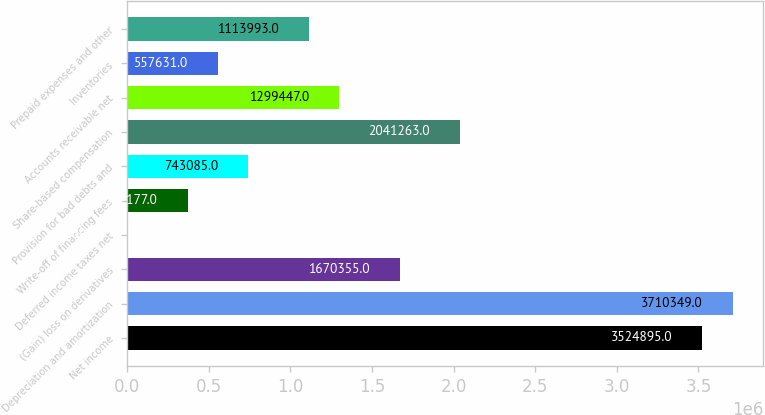Convert chart. <chart><loc_0><loc_0><loc_500><loc_500><bar_chart><fcel>Net income<fcel>Depreciation and amortization<fcel>(Gain) loss on derivatives<fcel>Deferred income taxes net<fcel>Write-off of financing fees<fcel>Provision for bad debts and<fcel>Share-based compensation<fcel>Accounts receivable net<fcel>Inventories<fcel>Prepaid expenses and other<nl><fcel>3.5249e+06<fcel>3.71035e+06<fcel>1.67036e+06<fcel>1269<fcel>372177<fcel>743085<fcel>2.04126e+06<fcel>1.29945e+06<fcel>557631<fcel>1.11399e+06<nl></chart> 